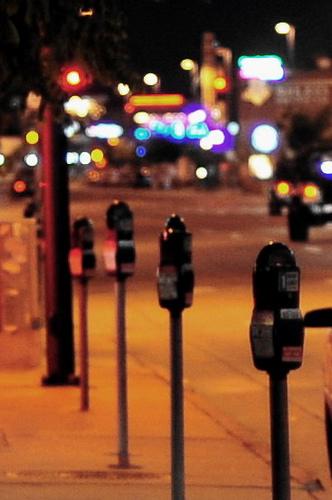What are the parking meters used for?
Short answer required. Paying. What time is it?
Quick response, please. Night. How much debris and litter is on the sidewalk?
Quick response, please. None. 